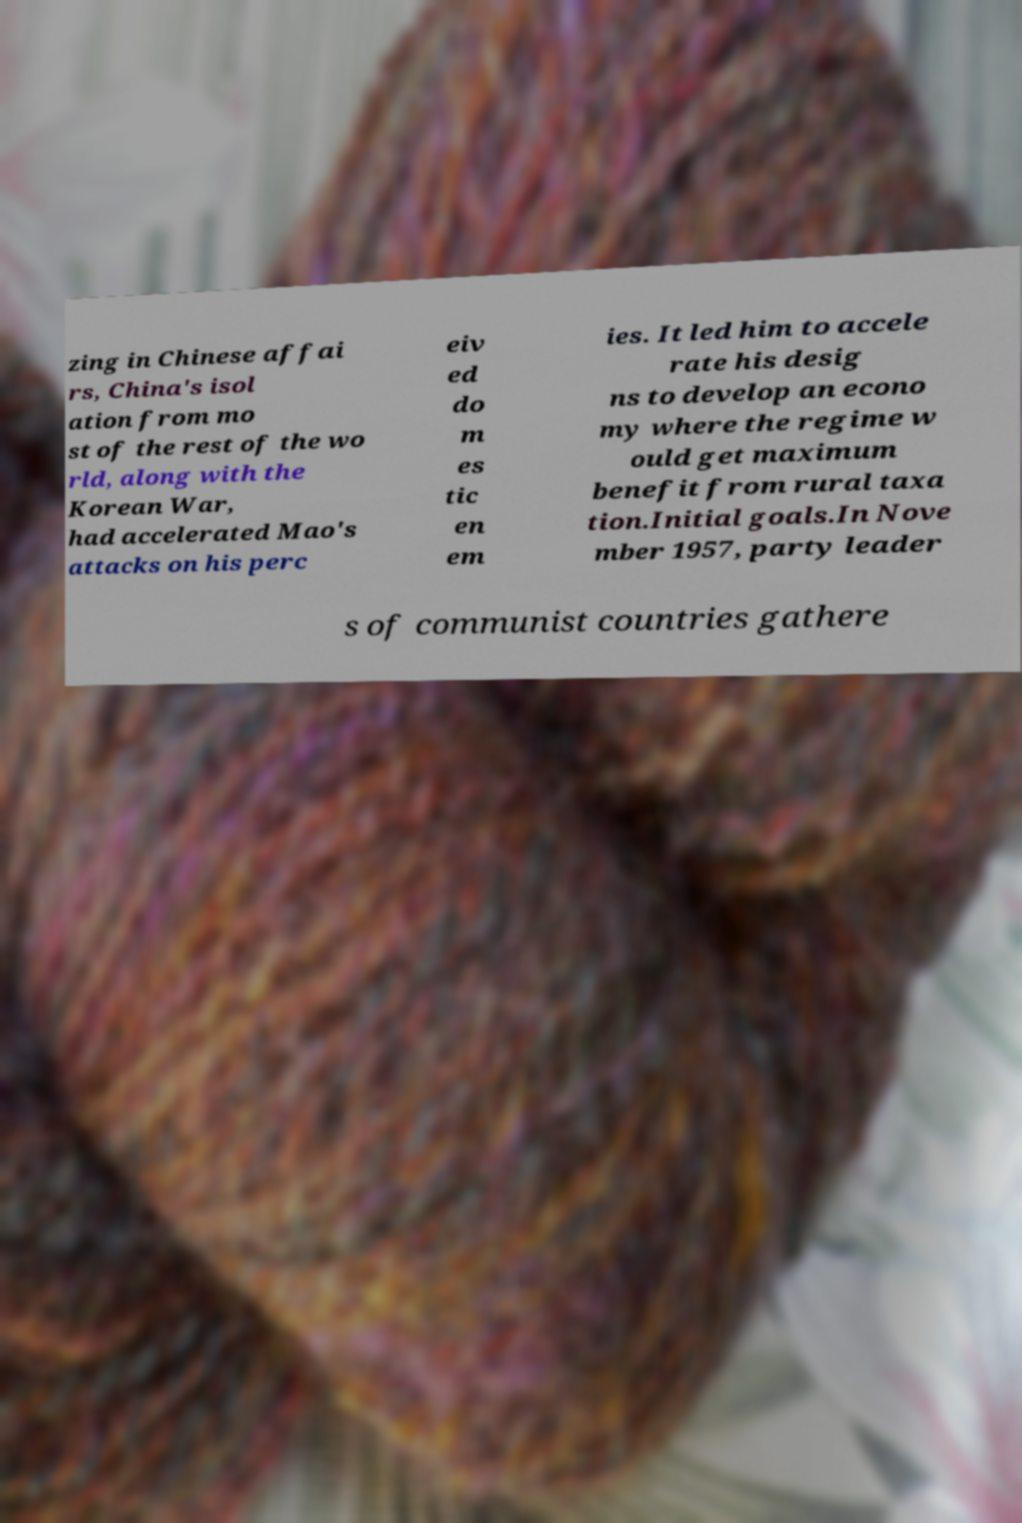Could you assist in decoding the text presented in this image and type it out clearly? zing in Chinese affai rs, China's isol ation from mo st of the rest of the wo rld, along with the Korean War, had accelerated Mao's attacks on his perc eiv ed do m es tic en em ies. It led him to accele rate his desig ns to develop an econo my where the regime w ould get maximum benefit from rural taxa tion.Initial goals.In Nove mber 1957, party leader s of communist countries gathere 